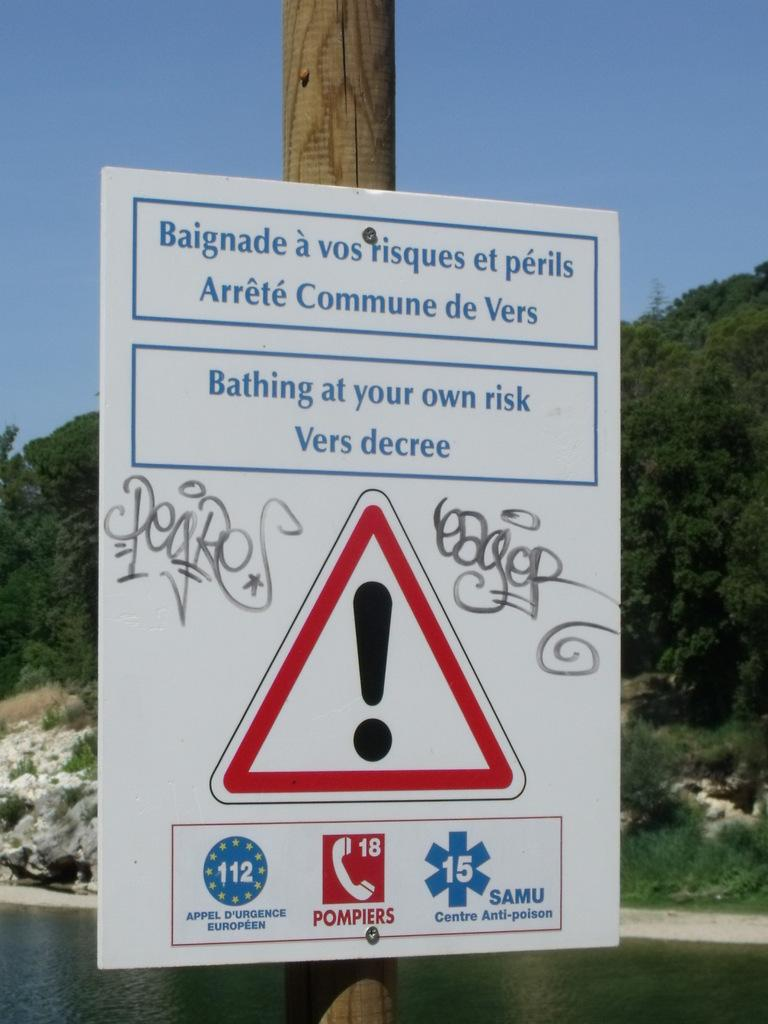What is the main object in the image? There is a signboard in the image. How is the signboard positioned in the image? The signboard is attached to a pole. What can be seen in the background of the image? Mountains, trees, and water are visible in the background of the image. What is the sister of the signboard doing in the image? There is no sister of the signboard present in the image. What type of division can be seen between the mountains and the water in the image? There is no division between the mountains and the water in the image; they are both visible in the background. 